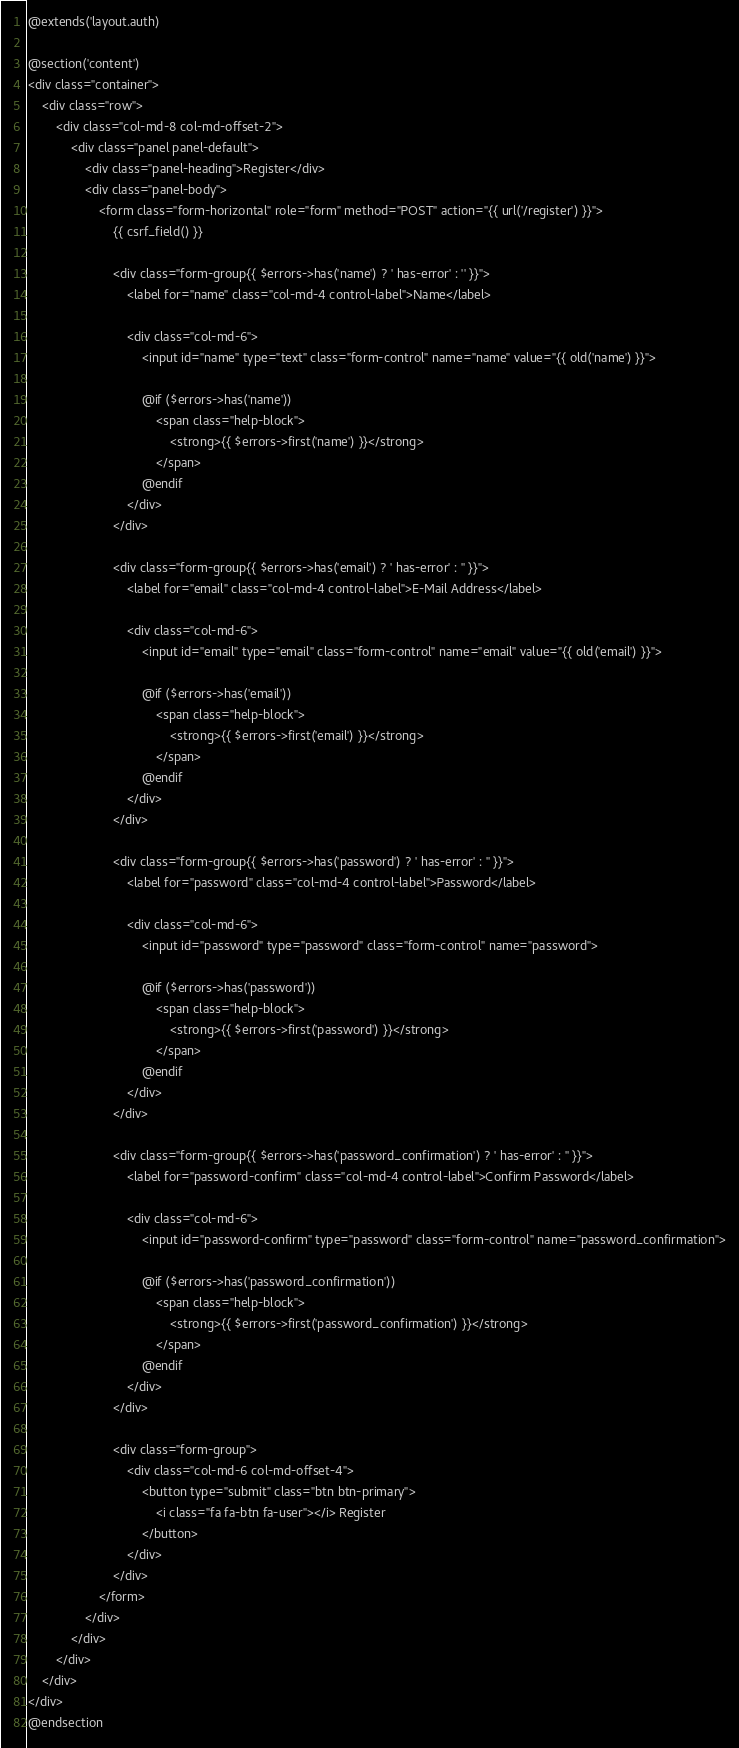Convert code to text. <code><loc_0><loc_0><loc_500><loc_500><_PHP_>@extends('layout.auth)

@section('content')
<div class="container">
    <div class="row">
        <div class="col-md-8 col-md-offset-2">
            <div class="panel panel-default">
                <div class="panel-heading">Register</div>
                <div class="panel-body">
                    <form class="form-horizontal" role="form" method="POST" action="{{ url('/register') }}">
                        {{ csrf_field() }}

                        <div class="form-group{{ $errors->has('name') ? ' has-error' : '' }}">
                            <label for="name" class="col-md-4 control-label">Name</label>

                            <div class="col-md-6">
                                <input id="name" type="text" class="form-control" name="name" value="{{ old('name') }}">

                                @if ($errors->has('name'))
                                    <span class="help-block">
                                        <strong>{{ $errors->first('name') }}</strong>
                                    </span>
                                @endif
                            </div>
                        </div>

                        <div class="form-group{{ $errors->has('email') ? ' has-error' : '' }}">
                            <label for="email" class="col-md-4 control-label">E-Mail Address</label>

                            <div class="col-md-6">
                                <input id="email" type="email" class="form-control" name="email" value="{{ old('email') }}">

                                @if ($errors->has('email'))
                                    <span class="help-block">
                                        <strong>{{ $errors->first('email') }}</strong>
                                    </span>
                                @endif
                            </div>
                        </div>

                        <div class="form-group{{ $errors->has('password') ? ' has-error' : '' }}">
                            <label for="password" class="col-md-4 control-label">Password</label>

                            <div class="col-md-6">
                                <input id="password" type="password" class="form-control" name="password">

                                @if ($errors->has('password'))
                                    <span class="help-block">
                                        <strong>{{ $errors->first('password') }}</strong>
                                    </span>
                                @endif
                            </div>
                        </div>

                        <div class="form-group{{ $errors->has('password_confirmation') ? ' has-error' : '' }}">
                            <label for="password-confirm" class="col-md-4 control-label">Confirm Password</label>

                            <div class="col-md-6">
                                <input id="password-confirm" type="password" class="form-control" name="password_confirmation">

                                @if ($errors->has('password_confirmation'))
                                    <span class="help-block">
                                        <strong>{{ $errors->first('password_confirmation') }}</strong>
                                    </span>
                                @endif
                            </div>
                        </div>

                        <div class="form-group">
                            <div class="col-md-6 col-md-offset-4">
                                <button type="submit" class="btn btn-primary">
                                    <i class="fa fa-btn fa-user"></i> Register
                                </button>
                            </div>
                        </div>
                    </form>
                </div>
            </div>
        </div>
    </div>
</div>
@endsection
</code> 